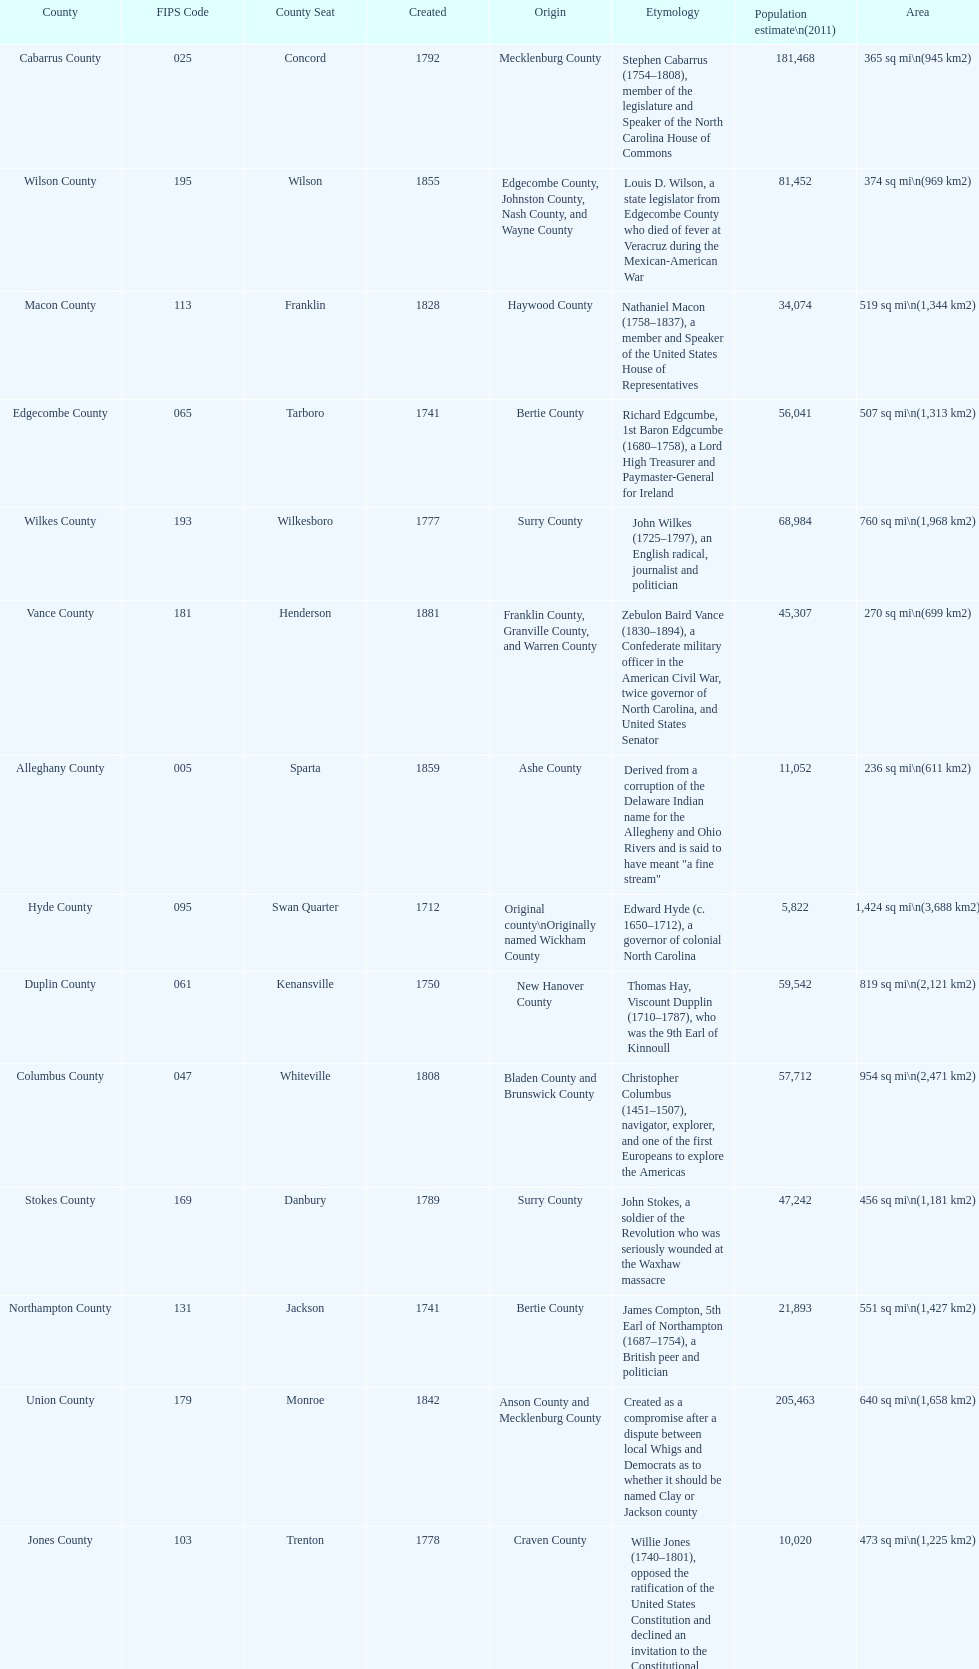Other than mecklenburg which county has the largest population? Wake County. 